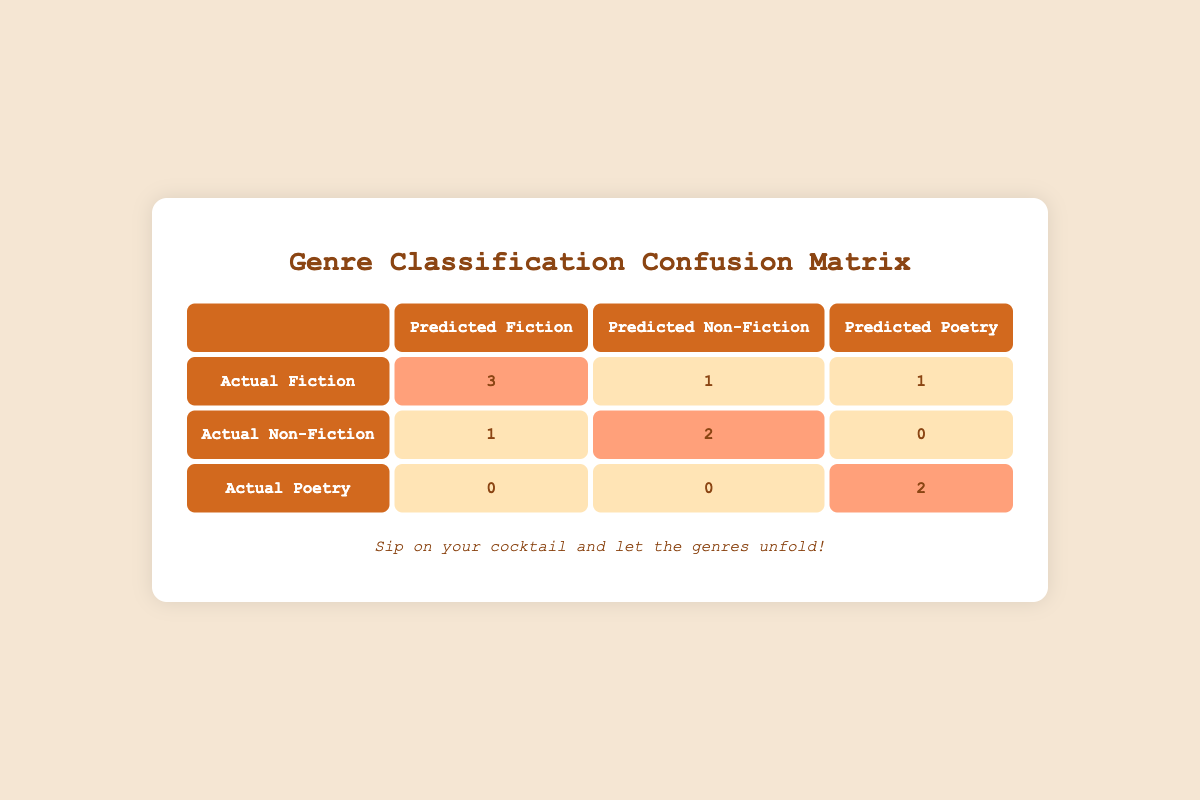What is the number of manuscripts correctly classified as Fiction? The table shows that 2 manuscripts were correctly classified as Fiction, indicated in the cell where Actual Fiction intersects with Predicted Fiction.
Answer: 2 How many manuscripts were misclassified as Non-Fiction but were actually Fiction? From the table, one manuscript was misclassified as Non-Fiction when it was actually Fiction, which is seen in the cell for Actual Fiction and Predicted Non-Fiction.
Answer: 1 What is the total number of Poetry manuscripts? To find the total number of actual Poetry manuscripts, we look at the corresponding row for Actual Poetry. There are 2 manuscripts as indicated in the highlighted cell for Actual Poetry and Predicted Poetry and 0 in other predicted categories.
Answer: 2 Did more manuscripts get classified correctly than incorrectly overall? To answer this, we count the correctly classified manuscripts (4: 2 Fiction, 2 Non-Fiction, 2 Poetry) and compare it with the total manuscripts misclassified (3: 1 Fiction, 1 Non-Fiction, 0 Poetry). Since correctly classified manuscripts are greater (4 > 3), the answer is Yes.
Answer: Yes What is the difference between the number of Fiction manuscripts correctly classified and those misclassified? From the table, 2 manuscripts are correctly classified as Fiction and 1 is misclassified as Non-Fiction. The difference is calculated as 2 (correct) - 1 (incorrect) = 1.
Answer: 1 How many manuscripts were predicted as Poetry? To find the total predicted as Poetry, we sum the counts in the Poetry column: 1 (misclassified as Non-Fiction) + 0 (which actually were Non-Fiction manuscripts) + 2 (correctly classified) = 3.
Answer: 3 What percentage of Non-Fiction manuscripts were correctly classified? There are 2 Non-Fiction manuscripts in total (highlighted cell for Actual Non-Fiction). The number correctly classified is also 2, so the percentage is (2 correct / 2 total) * 100% = 100%.
Answer: 100% Is it true that none of the Poetry manuscripts were misclassified as Fiction? In the table, the row for Actual Poetry shows that 0 manuscripts are misclassified as Fiction, confirming that none were misclassified in that category.
Answer: True 